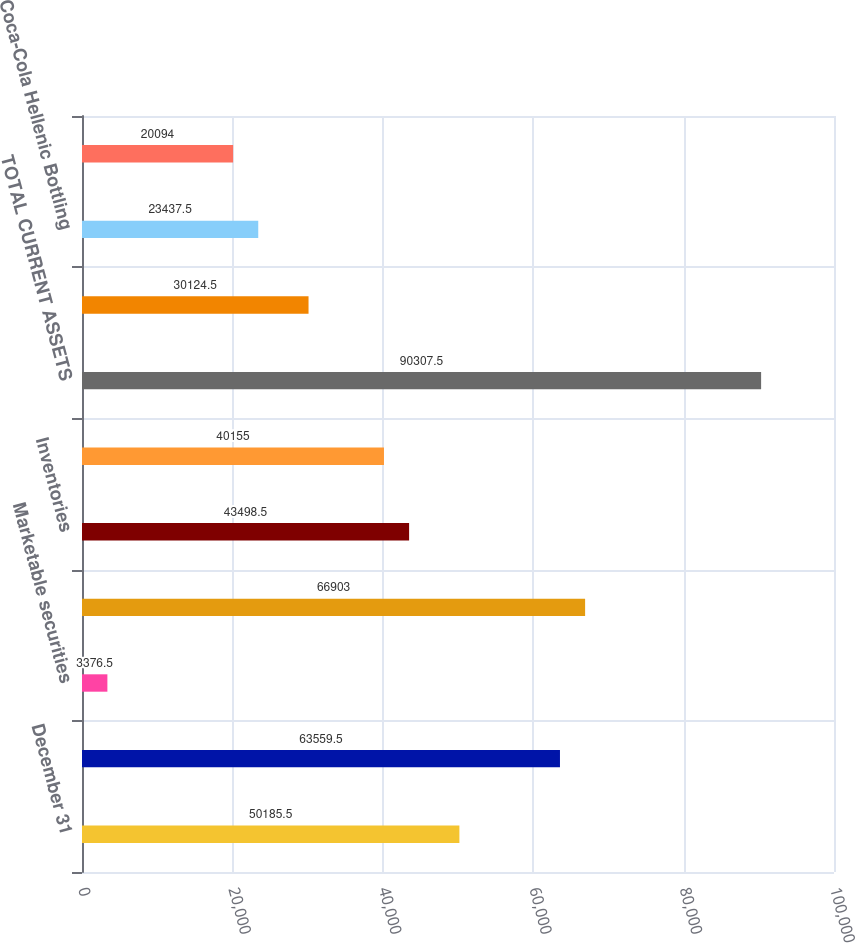Convert chart to OTSL. <chart><loc_0><loc_0><loc_500><loc_500><bar_chart><fcel>December 31<fcel>Cash and cash equivalents<fcel>Marketable securities<fcel>Trade accounts receivable less<fcel>Inventories<fcel>Prepaid expenses and other<fcel>TOTAL CURRENT ASSETS<fcel>Coca-Cola Enterprises Inc<fcel>Coca-Cola Hellenic Bottling<fcel>Coca-Cola FEMSA SAB de CV<nl><fcel>50185.5<fcel>63559.5<fcel>3376.5<fcel>66903<fcel>43498.5<fcel>40155<fcel>90307.5<fcel>30124.5<fcel>23437.5<fcel>20094<nl></chart> 